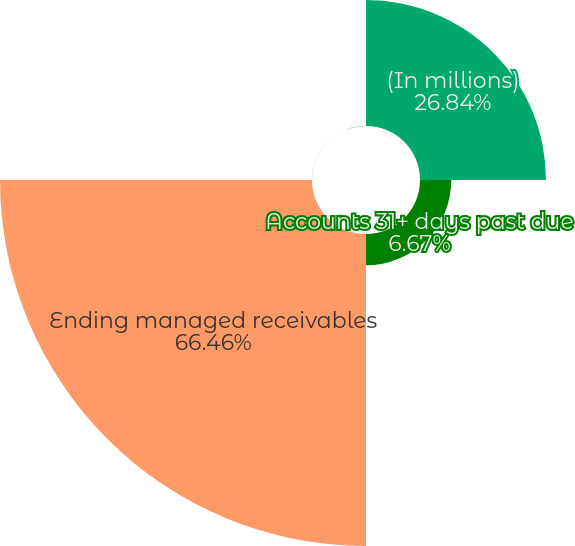<chart> <loc_0><loc_0><loc_500><loc_500><pie_chart><fcel>(In millions)<fcel>Accounts 31+ days past due<fcel>Ending managed receivables<fcel>Past due accounts as a<nl><fcel>26.84%<fcel>6.67%<fcel>66.46%<fcel>0.03%<nl></chart> 